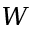<formula> <loc_0><loc_0><loc_500><loc_500>W</formula> 